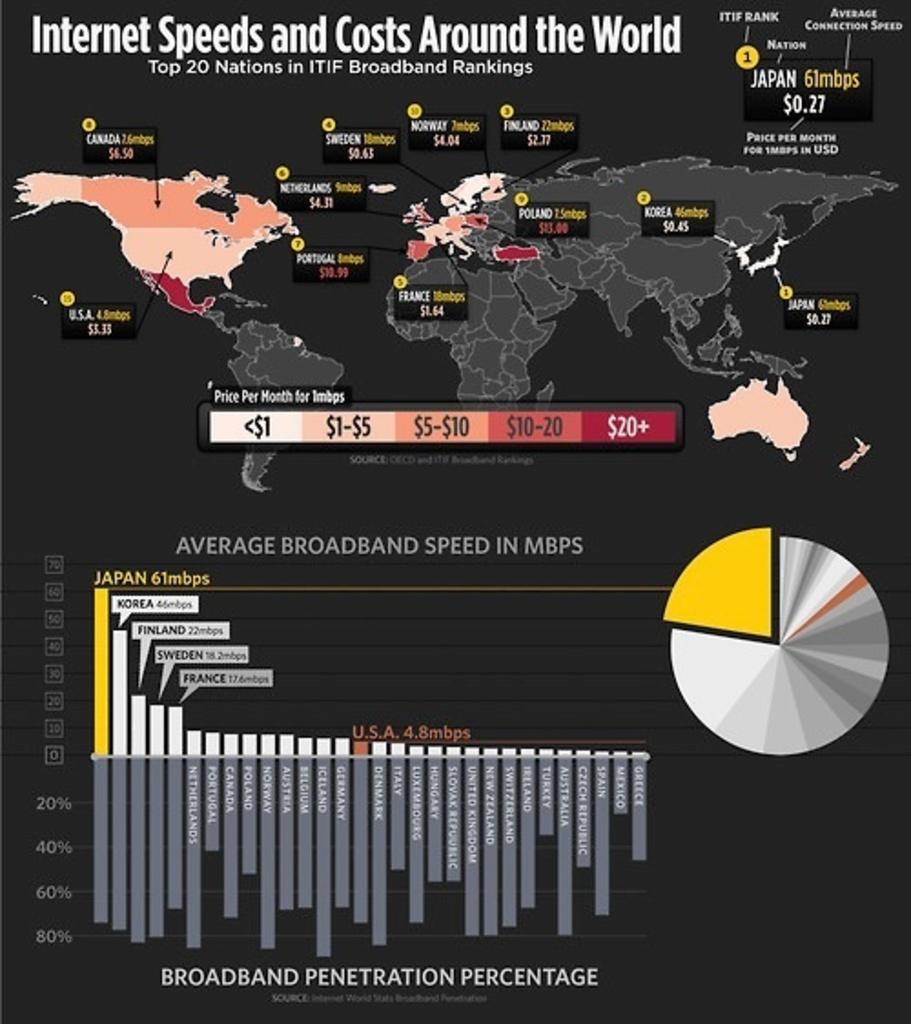What speed is being measured?
Give a very brief answer. Internet. What is the highest value number listed?
Your response must be concise. 61mbps. 